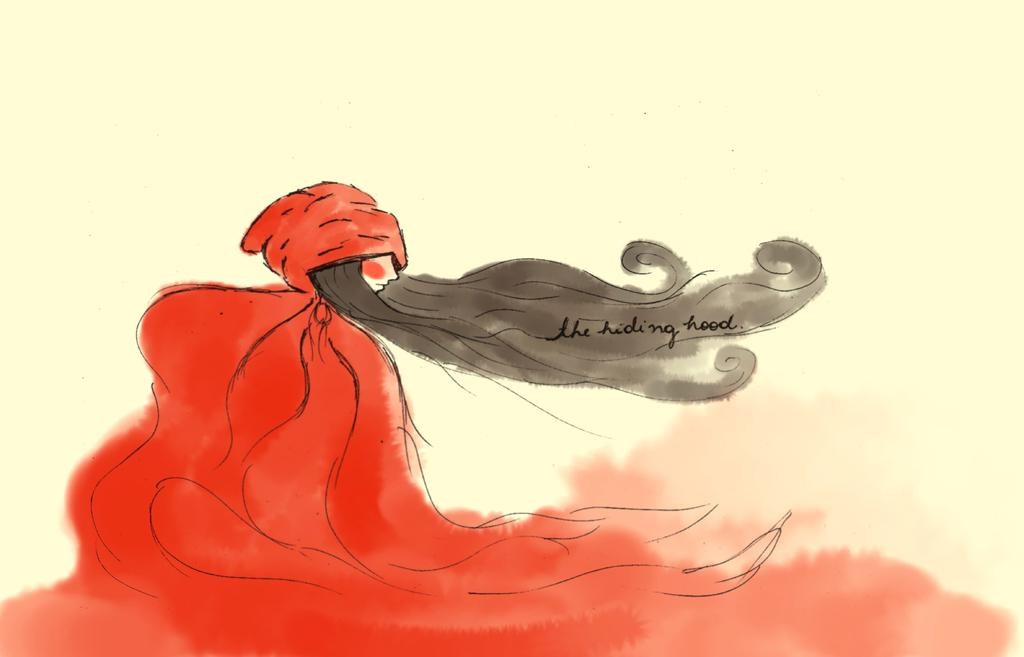What is the main subject of the image? The image contains a painting. What is depicted in the painting? The painting depicts a woman. What type of lace is the woman wearing in the painting? There is no mention of lace in the image or the painting, so it cannot be determined from the information provided. 